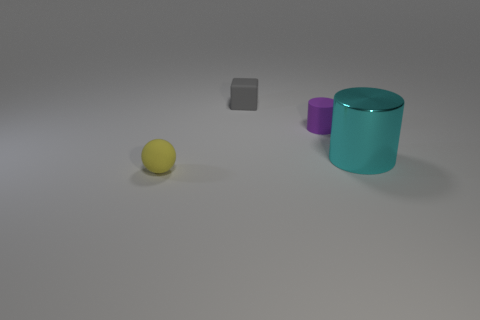What number of things are small gray rubber cubes or small balls? 2 